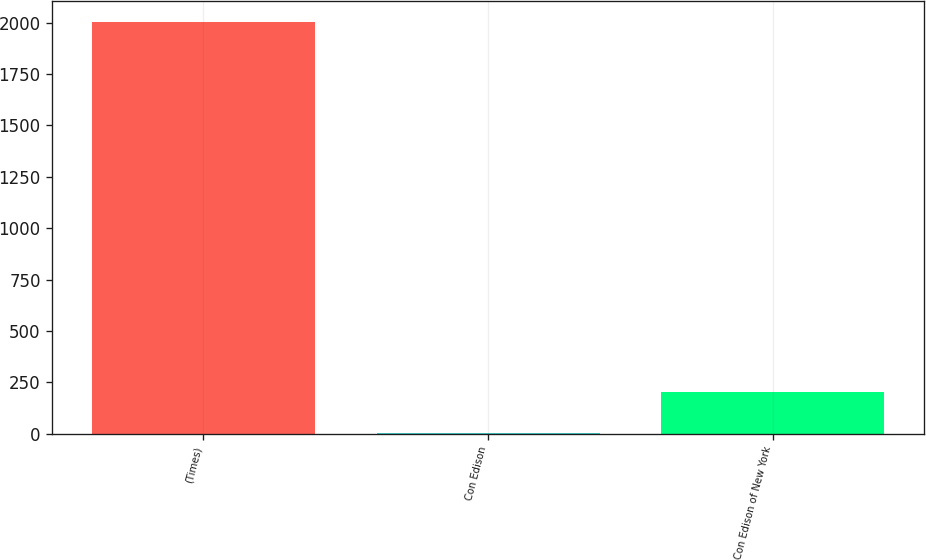Convert chart. <chart><loc_0><loc_0><loc_500><loc_500><bar_chart><fcel>(Times)<fcel>Con Edison<fcel>Con Edison of New York<nl><fcel>2004<fcel>2.6<fcel>202.74<nl></chart> 